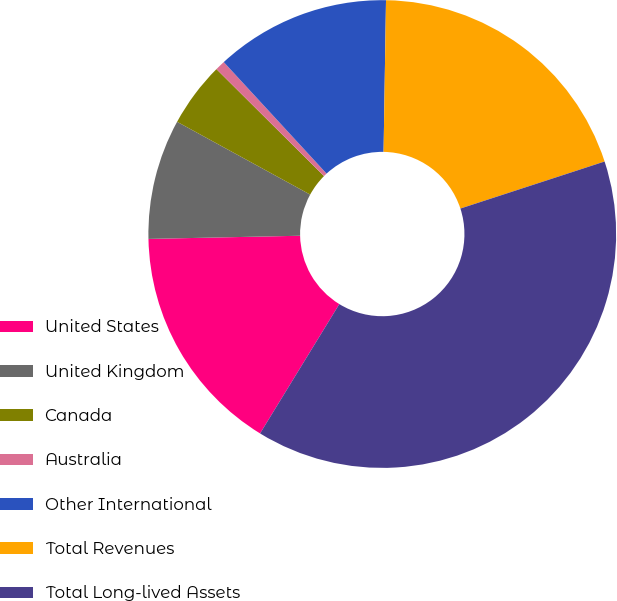Convert chart to OTSL. <chart><loc_0><loc_0><loc_500><loc_500><pie_chart><fcel>United States<fcel>United Kingdom<fcel>Canada<fcel>Australia<fcel>Other International<fcel>Total Revenues<fcel>Total Long-lived Assets<nl><fcel>15.92%<fcel>8.3%<fcel>4.49%<fcel>0.69%<fcel>12.11%<fcel>19.73%<fcel>38.77%<nl></chart> 